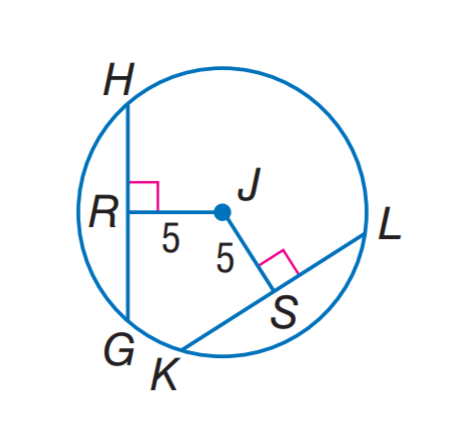Question: In \odot J, G H = 9 and K L = 4 x + 1. Find x.
Choices:
A. 2
B. 3
C. 5
D. 9
Answer with the letter. Answer: A 